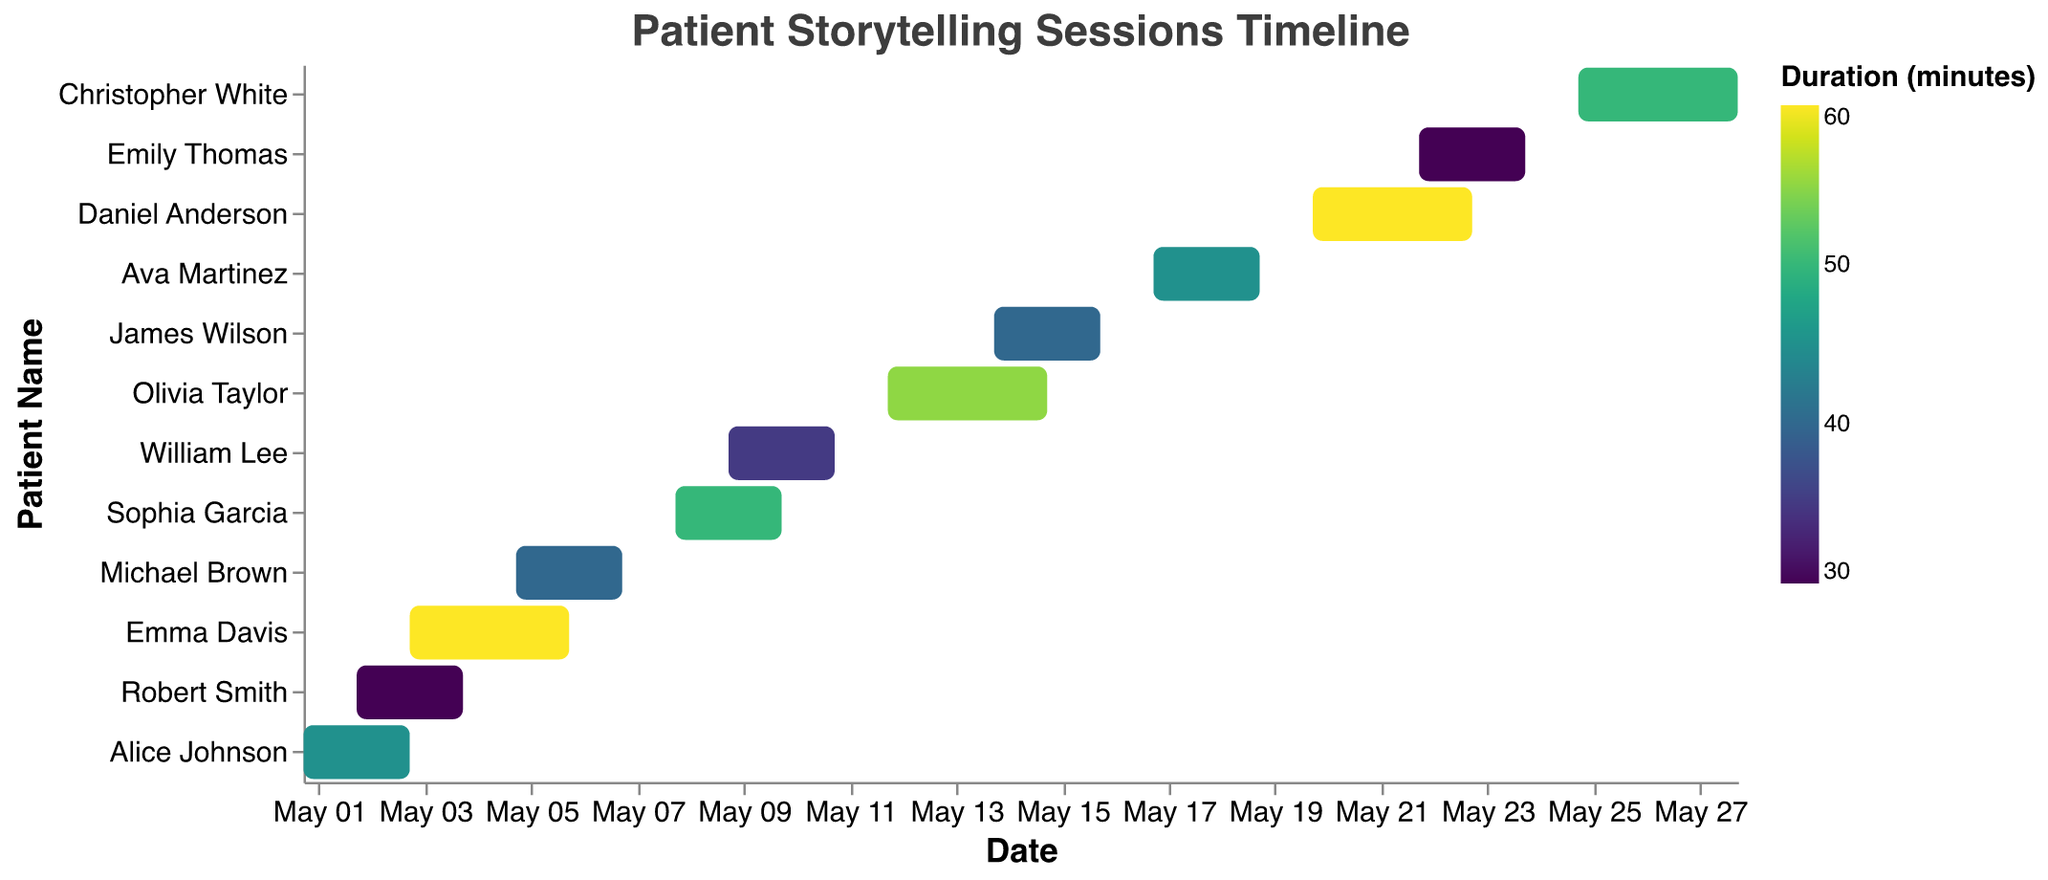What is the title of the figure? The title is located at the top of the figure and typically describes what the Gantt Chart is about.
Answer: Patient Storytelling Sessions Timeline Which patient had the longest storytelling session duration? By comparing the duration values given in the chart's color legend, the patient with the highest duration in minutes is identified.
Answer: Emma Davis and Daniel Anderson What is the duration (in minutes) of Robert Smith's storytelling session? By hovering over Robert Smith's entry in the chart, the tooltip reveals the duration of the session.
Answer: 30 How many days did Michael Brown's storytelling session span? By subtracting Michael Brown's start date from the end date and counting the days inclusive, the duration in days can be calculated.
Answer: 3 days Which storytelling session ended most recently? The end dates of all sessions are compared, and the latest date is identified as the most recent ending session.
Answer: Christopher White (2023-05-28) What is the average duration of all storytelling sessions? The total duration of all sessions is summed up and divided by the number of patients to find the average. Total duration (45+30+60+40+50+35+55+40+45+60+30+50) = 540, Number of patients = 12, Average = 540/12 = 45 minutes.
Answer: 45 minutes What is the total number of days covered by all storytelling sessions? For each session, calculate the number of days it spans by subtracting the start date from the end date and summing these durations. Total = (3-1+1) + (4-2+1) + (6-3+1) + (7-5+1) + (10-8+1) + (11-9+1) + (15-12+1) + (16-14+1) + (19-17+1) + (23-20+1) + (24-22+1) + (28-25+1) = 42 days.
Answer: 42 days Which patient had storytelling sessions overlapping with Emma Davis? By examining the timeline, anyone whose session start or end date overlaps with Emma Davis's session dates (2023-05-03 to 2023-05-06) is identified.
Answer: Robert Smith and Michael Brown How does the duration of James Wilson's session compare to Sophia Garcia's? By looking at the color gradients indicating duration, and checking the exact values provided in the legend, we determine if one is greater than, less than, or equal to the other. James Wilson's duration is 40 minutes, and Sophia Garcia's is 50 minutes.
Answer: James Wilson's session is shorter by 10 minutes Which patient had their session start on the same day another patient's session ended? By checking the timeline for consecutive entries where one patient's end date matches another patient's start date, this synchronization is identified. William Lee's session starts on 2023-05-09, the same day Sophia Garcia's session ends.
Answer: William Lee and Sophia Garcia 